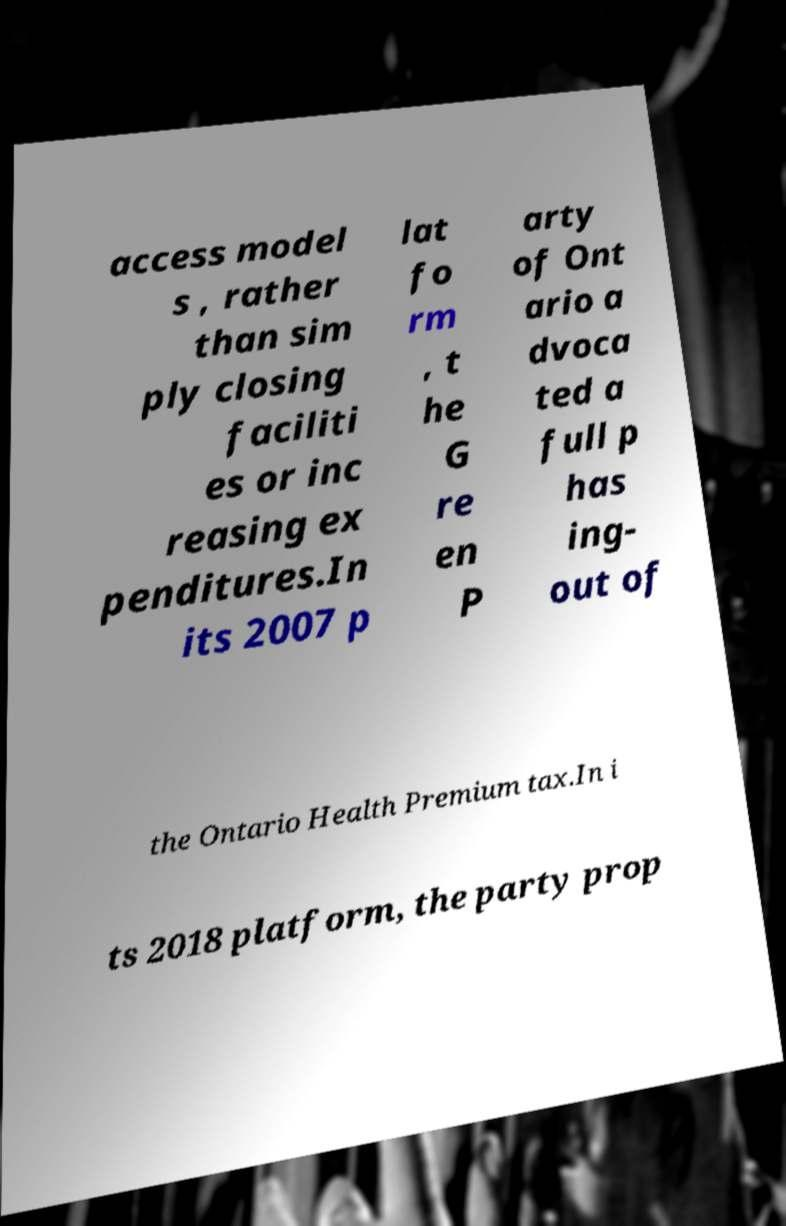Could you extract and type out the text from this image? access model s , rather than sim ply closing faciliti es or inc reasing ex penditures.In its 2007 p lat fo rm , t he G re en P arty of Ont ario a dvoca ted a full p has ing- out of the Ontario Health Premium tax.In i ts 2018 platform, the party prop 